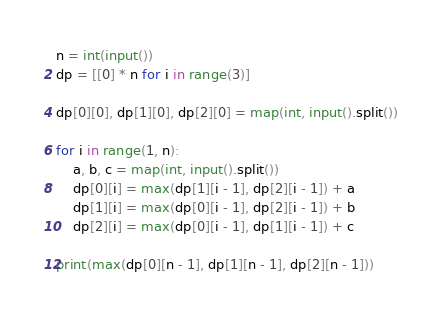<code> <loc_0><loc_0><loc_500><loc_500><_Python_>n = int(input())
dp = [[0] * n for i in range(3)]

dp[0][0], dp[1][0], dp[2][0] = map(int, input().split())

for i in range(1, n):
    a, b, c = map(int, input().split())
    dp[0][i] = max(dp[1][i - 1], dp[2][i - 1]) + a
    dp[1][i] = max(dp[0][i - 1], dp[2][i - 1]) + b
    dp[2][i] = max(dp[0][i - 1], dp[1][i - 1]) + c

print(max(dp[0][n - 1], dp[1][n - 1], dp[2][n - 1]))</code> 